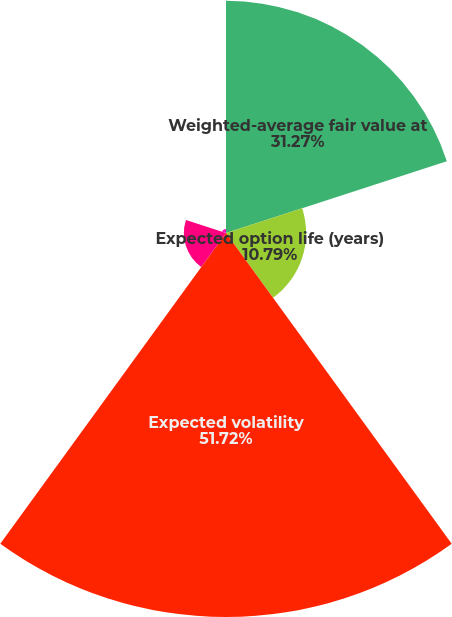Convert chart. <chart><loc_0><loc_0><loc_500><loc_500><pie_chart><fcel>Weighted-average fair value at<fcel>Expected option life (years)<fcel>Expected volatility<fcel>Risk-free interest rate at<fcel>Dividend yield (1)<nl><fcel>31.27%<fcel>10.79%<fcel>51.72%<fcel>5.67%<fcel>0.55%<nl></chart> 